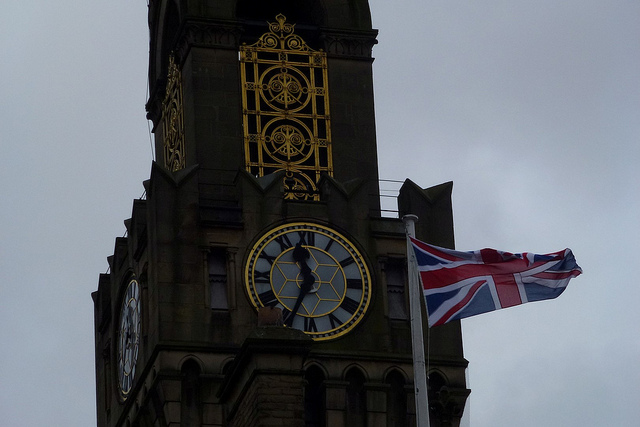What color is the statue? The statue in the image is a deep bronze color, which may appear darker from a distance or under different lighting conditions. 